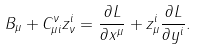Convert formula to latex. <formula><loc_0><loc_0><loc_500><loc_500>B _ { \mu } + C ^ { \nu } _ { \mu i } z ^ { i } _ { \nu } = \frac { \partial L } { \partial x ^ { \mu } } + z ^ { i } _ { \mu } \frac { \partial L } { \partial y ^ { i } } .</formula> 